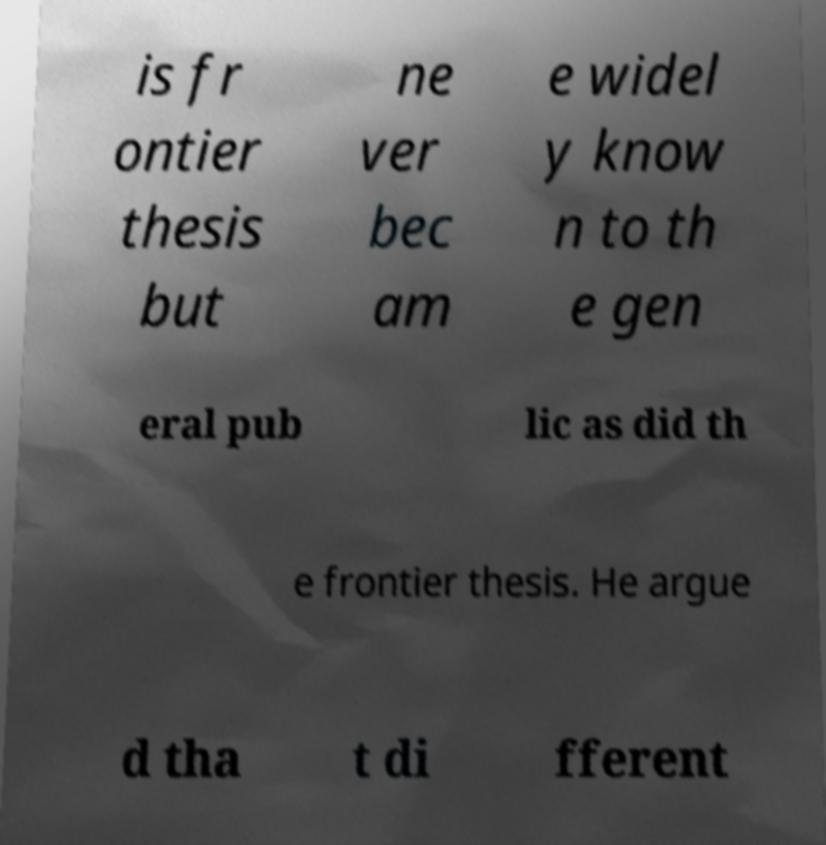Could you assist in decoding the text presented in this image and type it out clearly? is fr ontier thesis but ne ver bec am e widel y know n to th e gen eral pub lic as did th e frontier thesis. He argue d tha t di fferent 